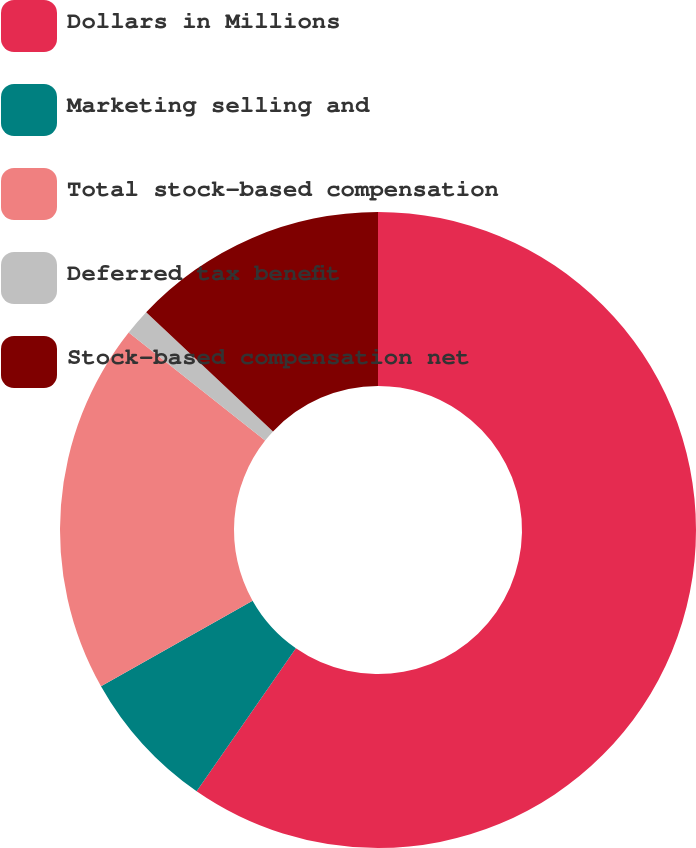Convert chart to OTSL. <chart><loc_0><loc_0><loc_500><loc_500><pie_chart><fcel>Dollars in Millions<fcel>Marketing selling and<fcel>Total stock-based compensation<fcel>Deferred tax benefit<fcel>Stock-based compensation net<nl><fcel>59.66%<fcel>7.17%<fcel>18.83%<fcel>1.34%<fcel>13.0%<nl></chart> 